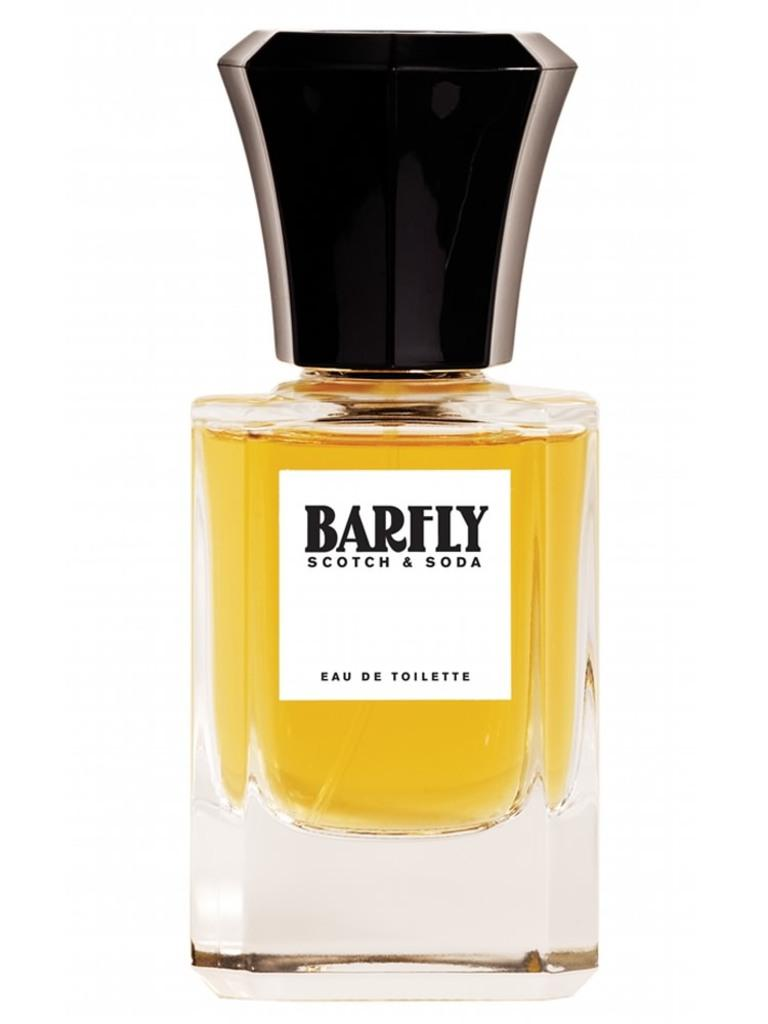<image>
Create a compact narrative representing the image presented. A bottle of Barfly Scotch & Soda perfume on display over a white background. 